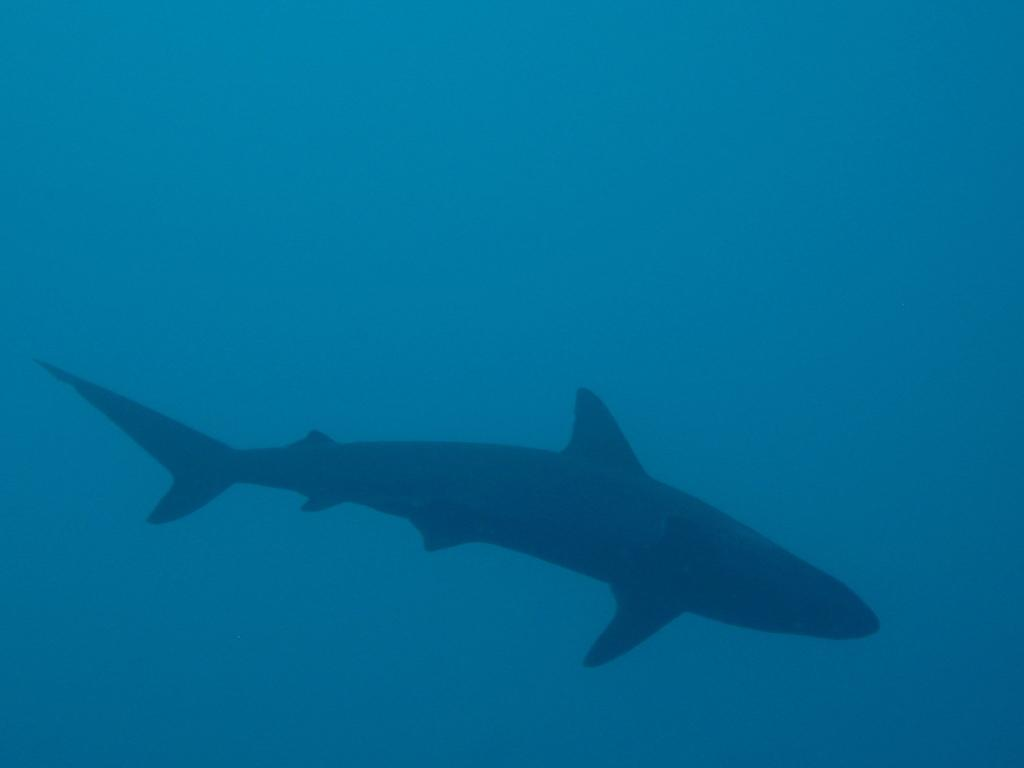What is the main subject of the image? There is a shark in the image. What color is the background of the image? The background of the image is blue. What type of fruit is hanging from the shark's fin in the image? There is no fruit present in the image, and the shark's fin does not have any fruit hanging from it. 